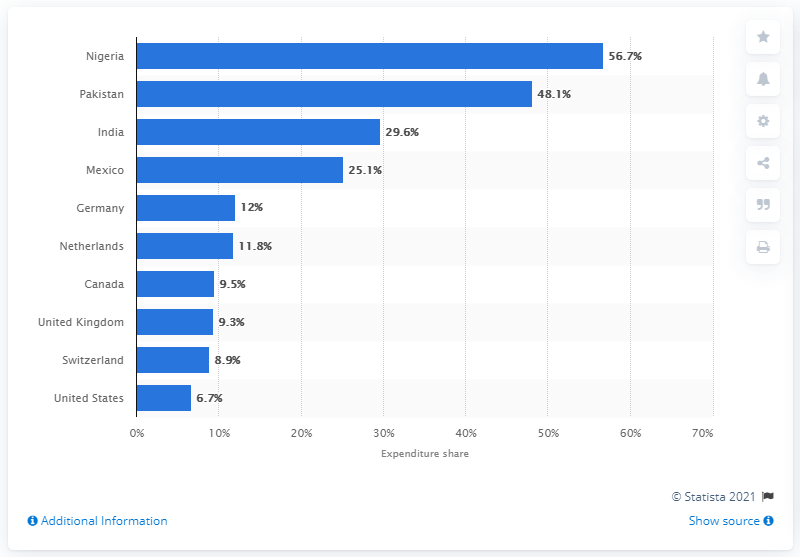Indicate a few pertinent items in this graphic. According to data, Americans spent approximately 6.7% of their disposable income on food at home in a given year. Pakistan's food expenditure share in 2013 was 48.1%. 